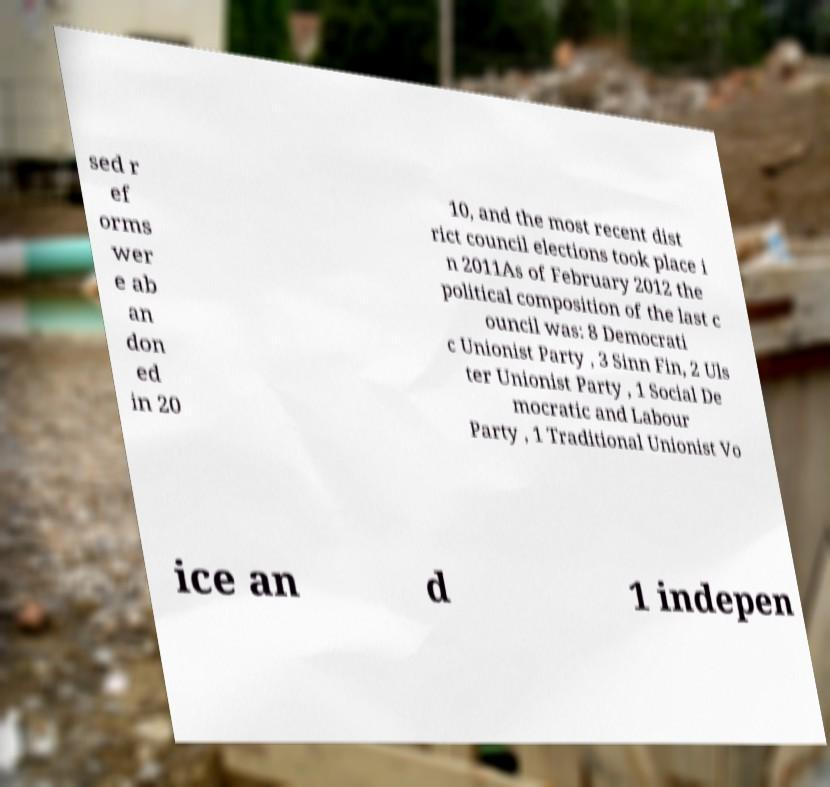For documentation purposes, I need the text within this image transcribed. Could you provide that? sed r ef orms wer e ab an don ed in 20 10, and the most recent dist rict council elections took place i n 2011As of February 2012 the political composition of the last c ouncil was: 8 Democrati c Unionist Party , 3 Sinn Fin, 2 Uls ter Unionist Party , 1 Social De mocratic and Labour Party , 1 Traditional Unionist Vo ice an d 1 indepen 